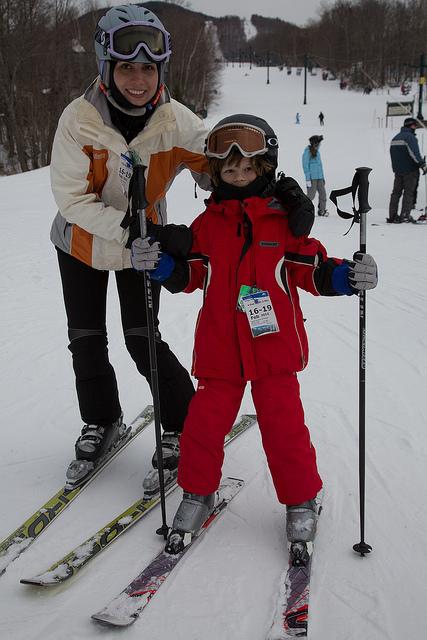Who is older?
Keep it brief. Woman. Who is taller?
Concise answer only. Woman. What is the participant's number?
Quick response, please. 16-19. What is the woman holding?
Answer briefly. Child. What are on their feet?
Short answer required. Skis. What are the glasses protecting the woman from?
Short answer required. Snow. 